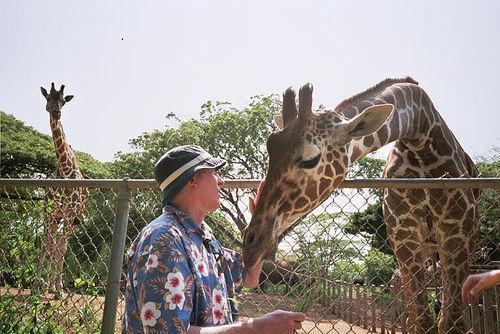How many giraffes are there?
Give a very brief answer. 2. How many people wearing hats?
Give a very brief answer. 1. How many giraffes are in the picture?
Give a very brief answer. 2. 